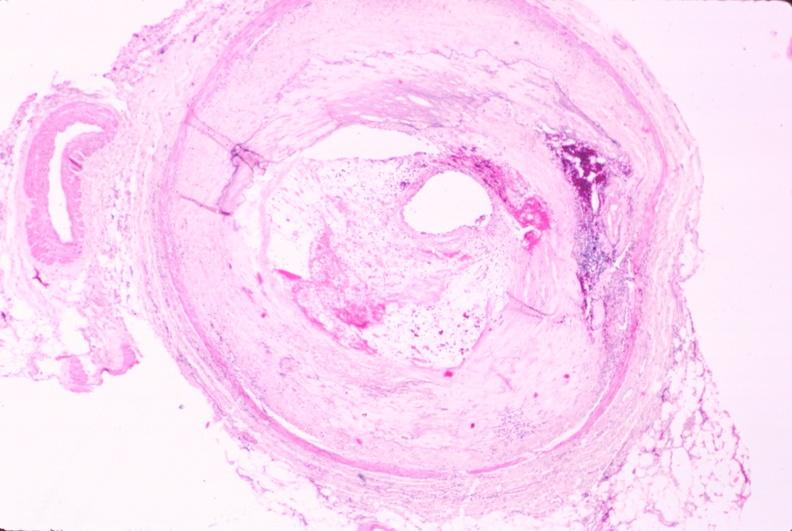does conjoined twins show atherosclerosis?
Answer the question using a single word or phrase. No 